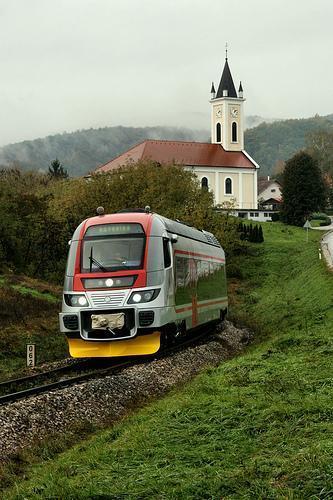How many windows can be seen on the church?
Give a very brief answer. 4. How many trains can be seen?
Give a very brief answer. 1. 